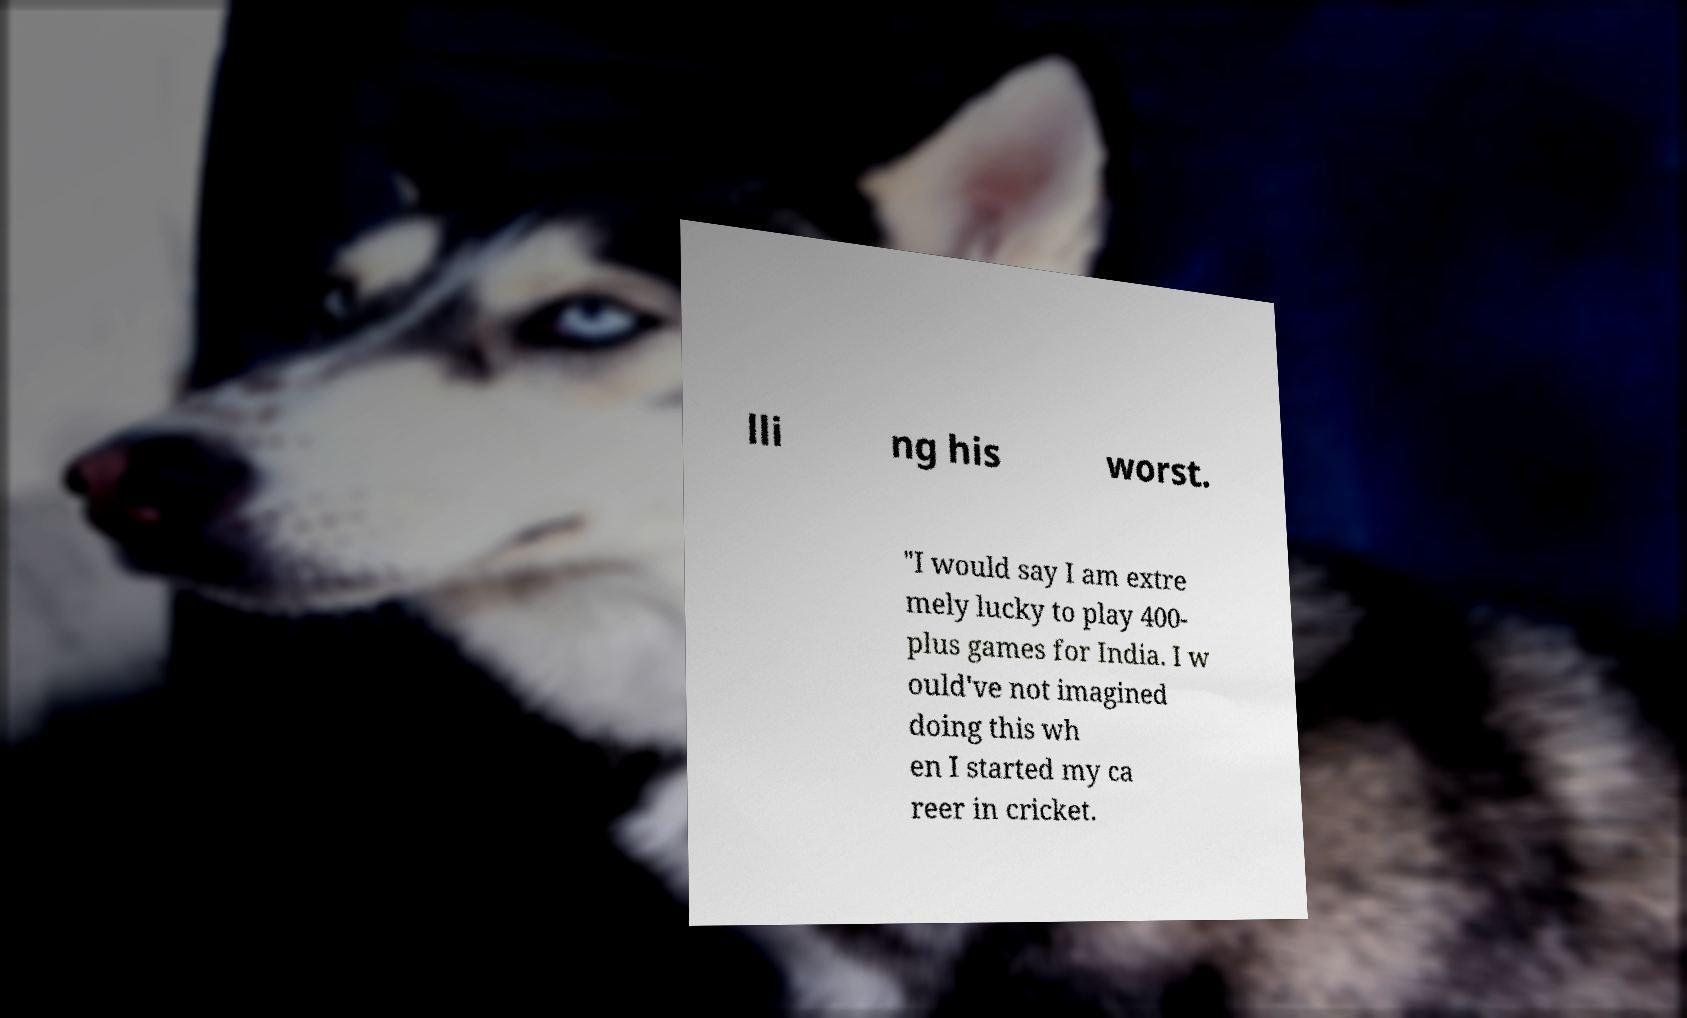I need the written content from this picture converted into text. Can you do that? lli ng his worst. "I would say I am extre mely lucky to play 400- plus games for India. I w ould've not imagined doing this wh en I started my ca reer in cricket. 